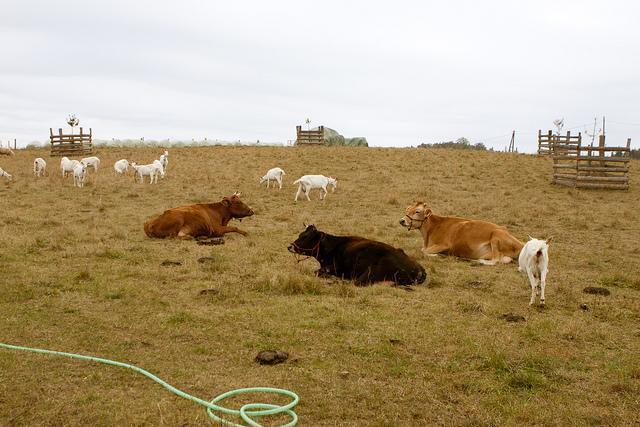How many brown cows are there?
Give a very brief answer. 3. How many cows are lying down?
Give a very brief answer. 3. How many black cows are there?
Give a very brief answer. 1. How many cows can be seen?
Give a very brief answer. 3. How many already fried donuts are there in the image?
Give a very brief answer. 0. 